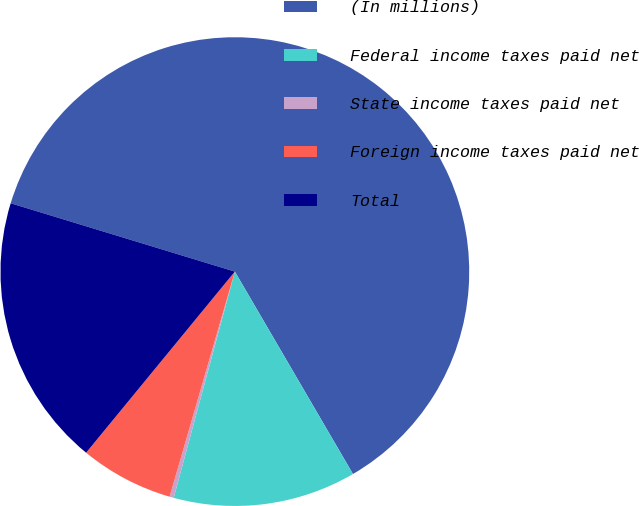Convert chart. <chart><loc_0><loc_0><loc_500><loc_500><pie_chart><fcel>(In millions)<fcel>Federal income taxes paid net<fcel>State income taxes paid net<fcel>Foreign income taxes paid net<fcel>Total<nl><fcel>61.89%<fcel>12.61%<fcel>0.29%<fcel>6.45%<fcel>18.77%<nl></chart> 